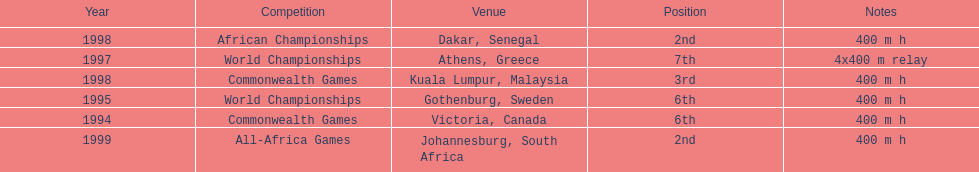Which year had the most competitions? 1998. 